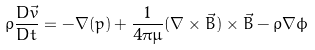<formula> <loc_0><loc_0><loc_500><loc_500>\rho \frac { D \vec { v } } { D t } = - \nabla ( p ) + \frac { 1 } { 4 \pi \mu } ( \nabla \times \vec { B } ) \times \vec { B } - \rho \nabla \phi</formula> 